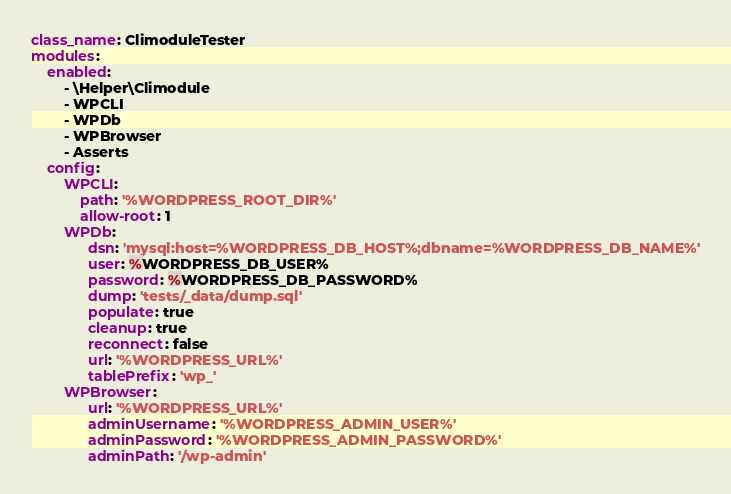<code> <loc_0><loc_0><loc_500><loc_500><_YAML_>class_name: ClimoduleTester
modules:
    enabled:
        - \Helper\Climodule
        - WPCLI
        - WPDb
        - WPBrowser
        - Asserts
    config:
        WPCLI:
            path: '%WORDPRESS_ROOT_DIR%'
            allow-root: 1
        WPDb:
              dsn: 'mysql:host=%WORDPRESS_DB_HOST%;dbname=%WORDPRESS_DB_NAME%'
              user: %WORDPRESS_DB_USER%
              password: %WORDPRESS_DB_PASSWORD%
              dump: 'tests/_data/dump.sql'
              populate: true
              cleanup: true
              reconnect: false
              url: '%WORDPRESS_URL%'
              tablePrefix: 'wp_'
        WPBrowser:
              url: '%WORDPRESS_URL%'
              adminUsername: '%WORDPRESS_ADMIN_USER%'
              adminPassword: '%WORDPRESS_ADMIN_PASSWORD%'
              adminPath: '/wp-admin'
</code> 